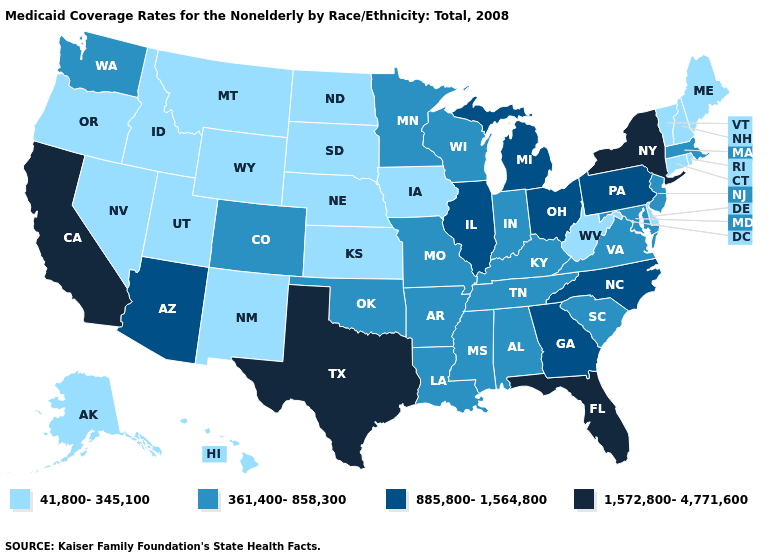Name the states that have a value in the range 361,400-858,300?
Short answer required. Alabama, Arkansas, Colorado, Indiana, Kentucky, Louisiana, Maryland, Massachusetts, Minnesota, Mississippi, Missouri, New Jersey, Oklahoma, South Carolina, Tennessee, Virginia, Washington, Wisconsin. Does Florida have the highest value in the USA?
Keep it brief. Yes. What is the value of Indiana?
Give a very brief answer. 361,400-858,300. Among the states that border Nebraska , does Missouri have the highest value?
Concise answer only. Yes. Which states have the lowest value in the Northeast?
Concise answer only. Connecticut, Maine, New Hampshire, Rhode Island, Vermont. Which states have the lowest value in the West?
Concise answer only. Alaska, Hawaii, Idaho, Montana, Nevada, New Mexico, Oregon, Utah, Wyoming. How many symbols are there in the legend?
Keep it brief. 4. Which states have the lowest value in the USA?
Keep it brief. Alaska, Connecticut, Delaware, Hawaii, Idaho, Iowa, Kansas, Maine, Montana, Nebraska, Nevada, New Hampshire, New Mexico, North Dakota, Oregon, Rhode Island, South Dakota, Utah, Vermont, West Virginia, Wyoming. What is the value of Maine?
Short answer required. 41,800-345,100. What is the value of North Dakota?
Write a very short answer. 41,800-345,100. What is the highest value in the MidWest ?
Concise answer only. 885,800-1,564,800. What is the value of North Dakota?
Keep it brief. 41,800-345,100. Does the map have missing data?
Give a very brief answer. No. Which states have the lowest value in the MidWest?
Answer briefly. Iowa, Kansas, Nebraska, North Dakota, South Dakota. 